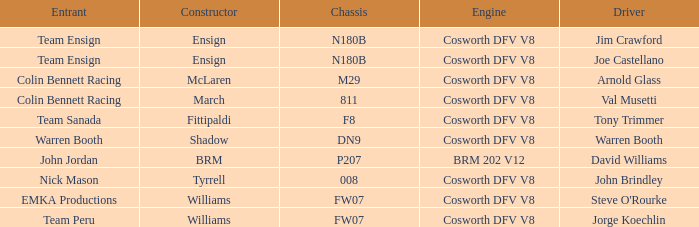What chassis does the shadow built car use? DN9. 